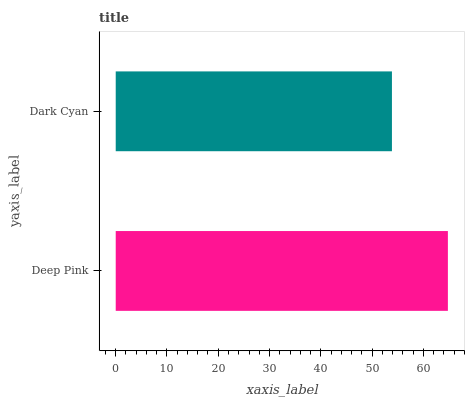Is Dark Cyan the minimum?
Answer yes or no. Yes. Is Deep Pink the maximum?
Answer yes or no. Yes. Is Dark Cyan the maximum?
Answer yes or no. No. Is Deep Pink greater than Dark Cyan?
Answer yes or no. Yes. Is Dark Cyan less than Deep Pink?
Answer yes or no. Yes. Is Dark Cyan greater than Deep Pink?
Answer yes or no. No. Is Deep Pink less than Dark Cyan?
Answer yes or no. No. Is Deep Pink the high median?
Answer yes or no. Yes. Is Dark Cyan the low median?
Answer yes or no. Yes. Is Dark Cyan the high median?
Answer yes or no. No. Is Deep Pink the low median?
Answer yes or no. No. 